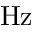<formula> <loc_0><loc_0><loc_500><loc_500>H z</formula> 